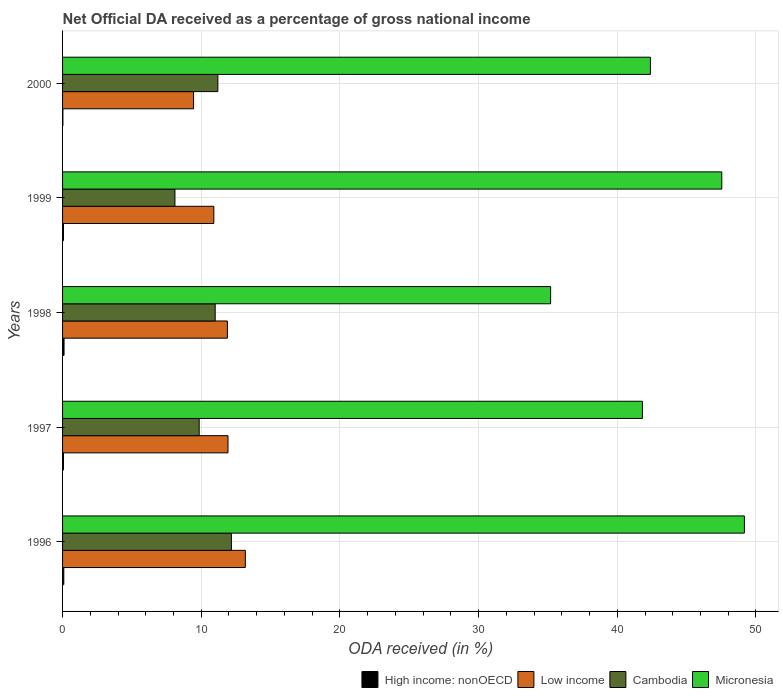How many different coloured bars are there?
Offer a terse response. 4. How many groups of bars are there?
Provide a succinct answer. 5. Are the number of bars per tick equal to the number of legend labels?
Make the answer very short. Yes. Are the number of bars on each tick of the Y-axis equal?
Provide a succinct answer. Yes. How many bars are there on the 4th tick from the bottom?
Offer a terse response. 4. What is the label of the 3rd group of bars from the top?
Your answer should be compact. 1998. In how many cases, is the number of bars for a given year not equal to the number of legend labels?
Keep it short and to the point. 0. What is the net official DA received in Cambodia in 1997?
Provide a succinct answer. 9.85. Across all years, what is the maximum net official DA received in Cambodia?
Offer a very short reply. 12.17. Across all years, what is the minimum net official DA received in Low income?
Your answer should be compact. 9.45. In which year was the net official DA received in Cambodia minimum?
Ensure brevity in your answer.  1999. What is the total net official DA received in High income: nonOECD in the graph?
Your response must be concise. 0.35. What is the difference between the net official DA received in Low income in 1999 and that in 2000?
Offer a terse response. 1.46. What is the difference between the net official DA received in Cambodia in 2000 and the net official DA received in Micronesia in 1998?
Provide a short and direct response. -24. What is the average net official DA received in Cambodia per year?
Your answer should be very brief. 10.47. In the year 1996, what is the difference between the net official DA received in Cambodia and net official DA received in Low income?
Your answer should be compact. -1.01. What is the ratio of the net official DA received in Micronesia in 1998 to that in 1999?
Ensure brevity in your answer.  0.74. Is the net official DA received in Micronesia in 1999 less than that in 2000?
Your answer should be very brief. No. Is the difference between the net official DA received in Cambodia in 1998 and 2000 greater than the difference between the net official DA received in Low income in 1998 and 2000?
Provide a succinct answer. No. What is the difference between the highest and the second highest net official DA received in High income: nonOECD?
Provide a short and direct response. 0.02. What is the difference between the highest and the lowest net official DA received in High income: nonOECD?
Ensure brevity in your answer.  0.08. In how many years, is the net official DA received in Cambodia greater than the average net official DA received in Cambodia taken over all years?
Make the answer very short. 3. Is the sum of the net official DA received in High income: nonOECD in 1996 and 1997 greater than the maximum net official DA received in Cambodia across all years?
Ensure brevity in your answer.  No. What does the 4th bar from the bottom in 1996 represents?
Provide a succinct answer. Micronesia. Is it the case that in every year, the sum of the net official DA received in High income: nonOECD and net official DA received in Cambodia is greater than the net official DA received in Low income?
Your answer should be very brief. No. How many bars are there?
Provide a short and direct response. 20. What is the difference between two consecutive major ticks on the X-axis?
Offer a very short reply. 10. Are the values on the major ticks of X-axis written in scientific E-notation?
Provide a short and direct response. No. Does the graph contain grids?
Offer a terse response. Yes. How are the legend labels stacked?
Provide a short and direct response. Horizontal. What is the title of the graph?
Offer a very short reply. Net Official DA received as a percentage of gross national income. What is the label or title of the X-axis?
Your answer should be very brief. ODA received (in %). What is the label or title of the Y-axis?
Offer a terse response. Years. What is the ODA received (in %) of High income: nonOECD in 1996?
Ensure brevity in your answer.  0.09. What is the ODA received (in %) in Low income in 1996?
Offer a very short reply. 13.18. What is the ODA received (in %) of Cambodia in 1996?
Provide a succinct answer. 12.17. What is the ODA received (in %) in Micronesia in 1996?
Your answer should be very brief. 49.17. What is the ODA received (in %) in High income: nonOECD in 1997?
Provide a succinct answer. 0.07. What is the ODA received (in %) in Low income in 1997?
Ensure brevity in your answer.  11.93. What is the ODA received (in %) of Cambodia in 1997?
Give a very brief answer. 9.85. What is the ODA received (in %) in Micronesia in 1997?
Provide a succinct answer. 41.81. What is the ODA received (in %) of High income: nonOECD in 1998?
Ensure brevity in your answer.  0.11. What is the ODA received (in %) of Low income in 1998?
Offer a very short reply. 11.89. What is the ODA received (in %) in Cambodia in 1998?
Offer a very short reply. 11.01. What is the ODA received (in %) in Micronesia in 1998?
Ensure brevity in your answer.  35.19. What is the ODA received (in %) of High income: nonOECD in 1999?
Provide a short and direct response. 0.07. What is the ODA received (in %) in Low income in 1999?
Your response must be concise. 10.91. What is the ODA received (in %) of Cambodia in 1999?
Provide a succinct answer. 8.1. What is the ODA received (in %) in Micronesia in 1999?
Provide a succinct answer. 47.54. What is the ODA received (in %) in High income: nonOECD in 2000?
Make the answer very short. 0.02. What is the ODA received (in %) in Low income in 2000?
Provide a short and direct response. 9.45. What is the ODA received (in %) in Cambodia in 2000?
Offer a very short reply. 11.2. What is the ODA received (in %) in Micronesia in 2000?
Provide a succinct answer. 42.39. Across all years, what is the maximum ODA received (in %) of High income: nonOECD?
Your answer should be very brief. 0.11. Across all years, what is the maximum ODA received (in %) in Low income?
Provide a succinct answer. 13.18. Across all years, what is the maximum ODA received (in %) in Cambodia?
Offer a very short reply. 12.17. Across all years, what is the maximum ODA received (in %) of Micronesia?
Your response must be concise. 49.17. Across all years, what is the minimum ODA received (in %) of High income: nonOECD?
Offer a very short reply. 0.02. Across all years, what is the minimum ODA received (in %) in Low income?
Provide a short and direct response. 9.45. Across all years, what is the minimum ODA received (in %) of Cambodia?
Give a very brief answer. 8.1. Across all years, what is the minimum ODA received (in %) in Micronesia?
Offer a terse response. 35.19. What is the total ODA received (in %) of High income: nonOECD in the graph?
Your answer should be compact. 0.35. What is the total ODA received (in %) in Low income in the graph?
Your response must be concise. 57.35. What is the total ODA received (in %) of Cambodia in the graph?
Make the answer very short. 52.33. What is the total ODA received (in %) of Micronesia in the graph?
Your answer should be very brief. 216.1. What is the difference between the ODA received (in %) of High income: nonOECD in 1996 and that in 1997?
Your response must be concise. 0.02. What is the difference between the ODA received (in %) in Low income in 1996 and that in 1997?
Make the answer very short. 1.25. What is the difference between the ODA received (in %) of Cambodia in 1996 and that in 1997?
Offer a very short reply. 2.32. What is the difference between the ODA received (in %) in Micronesia in 1996 and that in 1997?
Provide a short and direct response. 7.35. What is the difference between the ODA received (in %) of High income: nonOECD in 1996 and that in 1998?
Give a very brief answer. -0.02. What is the difference between the ODA received (in %) of Low income in 1996 and that in 1998?
Provide a short and direct response. 1.29. What is the difference between the ODA received (in %) in Cambodia in 1996 and that in 1998?
Make the answer very short. 1.17. What is the difference between the ODA received (in %) in Micronesia in 1996 and that in 1998?
Give a very brief answer. 13.97. What is the difference between the ODA received (in %) in High income: nonOECD in 1996 and that in 1999?
Your answer should be very brief. 0.02. What is the difference between the ODA received (in %) of Low income in 1996 and that in 1999?
Your response must be concise. 2.27. What is the difference between the ODA received (in %) of Cambodia in 1996 and that in 1999?
Provide a succinct answer. 4.07. What is the difference between the ODA received (in %) of Micronesia in 1996 and that in 1999?
Ensure brevity in your answer.  1.63. What is the difference between the ODA received (in %) in High income: nonOECD in 1996 and that in 2000?
Your answer should be very brief. 0.06. What is the difference between the ODA received (in %) of Low income in 1996 and that in 2000?
Provide a short and direct response. 3.73. What is the difference between the ODA received (in %) of Cambodia in 1996 and that in 2000?
Your answer should be very brief. 0.98. What is the difference between the ODA received (in %) in Micronesia in 1996 and that in 2000?
Your response must be concise. 6.78. What is the difference between the ODA received (in %) in High income: nonOECD in 1997 and that in 1998?
Give a very brief answer. -0.04. What is the difference between the ODA received (in %) in Low income in 1997 and that in 1998?
Give a very brief answer. 0.04. What is the difference between the ODA received (in %) of Cambodia in 1997 and that in 1998?
Offer a terse response. -1.15. What is the difference between the ODA received (in %) in Micronesia in 1997 and that in 1998?
Your answer should be compact. 6.62. What is the difference between the ODA received (in %) in High income: nonOECD in 1997 and that in 1999?
Make the answer very short. 0. What is the difference between the ODA received (in %) in Low income in 1997 and that in 1999?
Provide a succinct answer. 1.02. What is the difference between the ODA received (in %) of Cambodia in 1997 and that in 1999?
Ensure brevity in your answer.  1.75. What is the difference between the ODA received (in %) of Micronesia in 1997 and that in 1999?
Your answer should be very brief. -5.72. What is the difference between the ODA received (in %) in High income: nonOECD in 1997 and that in 2000?
Provide a short and direct response. 0.04. What is the difference between the ODA received (in %) of Low income in 1997 and that in 2000?
Give a very brief answer. 2.48. What is the difference between the ODA received (in %) of Cambodia in 1997 and that in 2000?
Provide a short and direct response. -1.35. What is the difference between the ODA received (in %) of Micronesia in 1997 and that in 2000?
Keep it short and to the point. -0.58. What is the difference between the ODA received (in %) of High income: nonOECD in 1998 and that in 1999?
Offer a very short reply. 0.04. What is the difference between the ODA received (in %) in Low income in 1998 and that in 1999?
Your answer should be compact. 0.98. What is the difference between the ODA received (in %) in Cambodia in 1998 and that in 1999?
Keep it short and to the point. 2.9. What is the difference between the ODA received (in %) in Micronesia in 1998 and that in 1999?
Provide a short and direct response. -12.34. What is the difference between the ODA received (in %) of High income: nonOECD in 1998 and that in 2000?
Your answer should be compact. 0.08. What is the difference between the ODA received (in %) in Low income in 1998 and that in 2000?
Make the answer very short. 2.44. What is the difference between the ODA received (in %) in Cambodia in 1998 and that in 2000?
Provide a short and direct response. -0.19. What is the difference between the ODA received (in %) of Micronesia in 1998 and that in 2000?
Provide a short and direct response. -7.2. What is the difference between the ODA received (in %) of High income: nonOECD in 1999 and that in 2000?
Make the answer very short. 0.04. What is the difference between the ODA received (in %) of Low income in 1999 and that in 2000?
Your answer should be very brief. 1.46. What is the difference between the ODA received (in %) of Cambodia in 1999 and that in 2000?
Offer a very short reply. -3.09. What is the difference between the ODA received (in %) in Micronesia in 1999 and that in 2000?
Keep it short and to the point. 5.15. What is the difference between the ODA received (in %) in High income: nonOECD in 1996 and the ODA received (in %) in Low income in 1997?
Provide a succinct answer. -11.84. What is the difference between the ODA received (in %) of High income: nonOECD in 1996 and the ODA received (in %) of Cambodia in 1997?
Keep it short and to the point. -9.76. What is the difference between the ODA received (in %) of High income: nonOECD in 1996 and the ODA received (in %) of Micronesia in 1997?
Your response must be concise. -41.72. What is the difference between the ODA received (in %) in Low income in 1996 and the ODA received (in %) in Cambodia in 1997?
Keep it short and to the point. 3.33. What is the difference between the ODA received (in %) of Low income in 1996 and the ODA received (in %) of Micronesia in 1997?
Keep it short and to the point. -28.63. What is the difference between the ODA received (in %) of Cambodia in 1996 and the ODA received (in %) of Micronesia in 1997?
Offer a terse response. -29.64. What is the difference between the ODA received (in %) of High income: nonOECD in 1996 and the ODA received (in %) of Low income in 1998?
Provide a short and direct response. -11.8. What is the difference between the ODA received (in %) in High income: nonOECD in 1996 and the ODA received (in %) in Cambodia in 1998?
Keep it short and to the point. -10.92. What is the difference between the ODA received (in %) of High income: nonOECD in 1996 and the ODA received (in %) of Micronesia in 1998?
Your answer should be very brief. -35.1. What is the difference between the ODA received (in %) of Low income in 1996 and the ODA received (in %) of Cambodia in 1998?
Ensure brevity in your answer.  2.17. What is the difference between the ODA received (in %) of Low income in 1996 and the ODA received (in %) of Micronesia in 1998?
Provide a succinct answer. -22.01. What is the difference between the ODA received (in %) of Cambodia in 1996 and the ODA received (in %) of Micronesia in 1998?
Offer a very short reply. -23.02. What is the difference between the ODA received (in %) in High income: nonOECD in 1996 and the ODA received (in %) in Low income in 1999?
Your response must be concise. -10.82. What is the difference between the ODA received (in %) in High income: nonOECD in 1996 and the ODA received (in %) in Cambodia in 1999?
Provide a short and direct response. -8.01. What is the difference between the ODA received (in %) in High income: nonOECD in 1996 and the ODA received (in %) in Micronesia in 1999?
Your answer should be very brief. -47.45. What is the difference between the ODA received (in %) in Low income in 1996 and the ODA received (in %) in Cambodia in 1999?
Ensure brevity in your answer.  5.08. What is the difference between the ODA received (in %) of Low income in 1996 and the ODA received (in %) of Micronesia in 1999?
Keep it short and to the point. -34.36. What is the difference between the ODA received (in %) in Cambodia in 1996 and the ODA received (in %) in Micronesia in 1999?
Make the answer very short. -35.36. What is the difference between the ODA received (in %) in High income: nonOECD in 1996 and the ODA received (in %) in Low income in 2000?
Provide a succinct answer. -9.36. What is the difference between the ODA received (in %) of High income: nonOECD in 1996 and the ODA received (in %) of Cambodia in 2000?
Offer a terse response. -11.11. What is the difference between the ODA received (in %) in High income: nonOECD in 1996 and the ODA received (in %) in Micronesia in 2000?
Your answer should be very brief. -42.3. What is the difference between the ODA received (in %) of Low income in 1996 and the ODA received (in %) of Cambodia in 2000?
Ensure brevity in your answer.  1.98. What is the difference between the ODA received (in %) in Low income in 1996 and the ODA received (in %) in Micronesia in 2000?
Offer a terse response. -29.21. What is the difference between the ODA received (in %) in Cambodia in 1996 and the ODA received (in %) in Micronesia in 2000?
Offer a very short reply. -30.22. What is the difference between the ODA received (in %) in High income: nonOECD in 1997 and the ODA received (in %) in Low income in 1998?
Give a very brief answer. -11.82. What is the difference between the ODA received (in %) in High income: nonOECD in 1997 and the ODA received (in %) in Cambodia in 1998?
Ensure brevity in your answer.  -10.94. What is the difference between the ODA received (in %) in High income: nonOECD in 1997 and the ODA received (in %) in Micronesia in 1998?
Make the answer very short. -35.13. What is the difference between the ODA received (in %) in Low income in 1997 and the ODA received (in %) in Cambodia in 1998?
Your response must be concise. 0.92. What is the difference between the ODA received (in %) of Low income in 1997 and the ODA received (in %) of Micronesia in 1998?
Give a very brief answer. -23.26. What is the difference between the ODA received (in %) in Cambodia in 1997 and the ODA received (in %) in Micronesia in 1998?
Make the answer very short. -25.34. What is the difference between the ODA received (in %) in High income: nonOECD in 1997 and the ODA received (in %) in Low income in 1999?
Offer a very short reply. -10.84. What is the difference between the ODA received (in %) of High income: nonOECD in 1997 and the ODA received (in %) of Cambodia in 1999?
Your response must be concise. -8.04. What is the difference between the ODA received (in %) of High income: nonOECD in 1997 and the ODA received (in %) of Micronesia in 1999?
Your answer should be very brief. -47.47. What is the difference between the ODA received (in %) in Low income in 1997 and the ODA received (in %) in Cambodia in 1999?
Provide a short and direct response. 3.83. What is the difference between the ODA received (in %) of Low income in 1997 and the ODA received (in %) of Micronesia in 1999?
Your response must be concise. -35.61. What is the difference between the ODA received (in %) of Cambodia in 1997 and the ODA received (in %) of Micronesia in 1999?
Keep it short and to the point. -37.68. What is the difference between the ODA received (in %) in High income: nonOECD in 1997 and the ODA received (in %) in Low income in 2000?
Your answer should be compact. -9.38. What is the difference between the ODA received (in %) in High income: nonOECD in 1997 and the ODA received (in %) in Cambodia in 2000?
Offer a terse response. -11.13. What is the difference between the ODA received (in %) in High income: nonOECD in 1997 and the ODA received (in %) in Micronesia in 2000?
Give a very brief answer. -42.32. What is the difference between the ODA received (in %) in Low income in 1997 and the ODA received (in %) in Cambodia in 2000?
Ensure brevity in your answer.  0.73. What is the difference between the ODA received (in %) in Low income in 1997 and the ODA received (in %) in Micronesia in 2000?
Keep it short and to the point. -30.46. What is the difference between the ODA received (in %) in Cambodia in 1997 and the ODA received (in %) in Micronesia in 2000?
Your answer should be very brief. -32.54. What is the difference between the ODA received (in %) of High income: nonOECD in 1998 and the ODA received (in %) of Low income in 1999?
Provide a short and direct response. -10.8. What is the difference between the ODA received (in %) in High income: nonOECD in 1998 and the ODA received (in %) in Cambodia in 1999?
Offer a very short reply. -8. What is the difference between the ODA received (in %) of High income: nonOECD in 1998 and the ODA received (in %) of Micronesia in 1999?
Offer a very short reply. -47.43. What is the difference between the ODA received (in %) in Low income in 1998 and the ODA received (in %) in Cambodia in 1999?
Your response must be concise. 3.78. What is the difference between the ODA received (in %) in Low income in 1998 and the ODA received (in %) in Micronesia in 1999?
Offer a very short reply. -35.65. What is the difference between the ODA received (in %) of Cambodia in 1998 and the ODA received (in %) of Micronesia in 1999?
Your response must be concise. -36.53. What is the difference between the ODA received (in %) in High income: nonOECD in 1998 and the ODA received (in %) in Low income in 2000?
Ensure brevity in your answer.  -9.34. What is the difference between the ODA received (in %) in High income: nonOECD in 1998 and the ODA received (in %) in Cambodia in 2000?
Your response must be concise. -11.09. What is the difference between the ODA received (in %) in High income: nonOECD in 1998 and the ODA received (in %) in Micronesia in 2000?
Keep it short and to the point. -42.28. What is the difference between the ODA received (in %) of Low income in 1998 and the ODA received (in %) of Cambodia in 2000?
Offer a terse response. 0.69. What is the difference between the ODA received (in %) in Low income in 1998 and the ODA received (in %) in Micronesia in 2000?
Offer a terse response. -30.5. What is the difference between the ODA received (in %) in Cambodia in 1998 and the ODA received (in %) in Micronesia in 2000?
Keep it short and to the point. -31.38. What is the difference between the ODA received (in %) of High income: nonOECD in 1999 and the ODA received (in %) of Low income in 2000?
Your response must be concise. -9.38. What is the difference between the ODA received (in %) of High income: nonOECD in 1999 and the ODA received (in %) of Cambodia in 2000?
Offer a terse response. -11.13. What is the difference between the ODA received (in %) in High income: nonOECD in 1999 and the ODA received (in %) in Micronesia in 2000?
Your response must be concise. -42.32. What is the difference between the ODA received (in %) of Low income in 1999 and the ODA received (in %) of Cambodia in 2000?
Offer a terse response. -0.29. What is the difference between the ODA received (in %) in Low income in 1999 and the ODA received (in %) in Micronesia in 2000?
Provide a succinct answer. -31.48. What is the difference between the ODA received (in %) of Cambodia in 1999 and the ODA received (in %) of Micronesia in 2000?
Provide a succinct answer. -34.29. What is the average ODA received (in %) of High income: nonOECD per year?
Give a very brief answer. 0.07. What is the average ODA received (in %) of Low income per year?
Provide a short and direct response. 11.47. What is the average ODA received (in %) in Cambodia per year?
Offer a terse response. 10.47. What is the average ODA received (in %) in Micronesia per year?
Provide a succinct answer. 43.22. In the year 1996, what is the difference between the ODA received (in %) of High income: nonOECD and ODA received (in %) of Low income?
Keep it short and to the point. -13.09. In the year 1996, what is the difference between the ODA received (in %) of High income: nonOECD and ODA received (in %) of Cambodia?
Offer a very short reply. -12.09. In the year 1996, what is the difference between the ODA received (in %) of High income: nonOECD and ODA received (in %) of Micronesia?
Ensure brevity in your answer.  -49.08. In the year 1996, what is the difference between the ODA received (in %) of Low income and ODA received (in %) of Cambodia?
Offer a very short reply. 1.01. In the year 1996, what is the difference between the ODA received (in %) of Low income and ODA received (in %) of Micronesia?
Give a very brief answer. -35.99. In the year 1996, what is the difference between the ODA received (in %) of Cambodia and ODA received (in %) of Micronesia?
Your answer should be compact. -36.99. In the year 1997, what is the difference between the ODA received (in %) of High income: nonOECD and ODA received (in %) of Low income?
Keep it short and to the point. -11.86. In the year 1997, what is the difference between the ODA received (in %) in High income: nonOECD and ODA received (in %) in Cambodia?
Your answer should be very brief. -9.78. In the year 1997, what is the difference between the ODA received (in %) of High income: nonOECD and ODA received (in %) of Micronesia?
Provide a short and direct response. -41.74. In the year 1997, what is the difference between the ODA received (in %) of Low income and ODA received (in %) of Cambodia?
Offer a terse response. 2.08. In the year 1997, what is the difference between the ODA received (in %) in Low income and ODA received (in %) in Micronesia?
Your answer should be very brief. -29.88. In the year 1997, what is the difference between the ODA received (in %) in Cambodia and ODA received (in %) in Micronesia?
Your answer should be compact. -31.96. In the year 1998, what is the difference between the ODA received (in %) of High income: nonOECD and ODA received (in %) of Low income?
Provide a short and direct response. -11.78. In the year 1998, what is the difference between the ODA received (in %) in High income: nonOECD and ODA received (in %) in Cambodia?
Ensure brevity in your answer.  -10.9. In the year 1998, what is the difference between the ODA received (in %) in High income: nonOECD and ODA received (in %) in Micronesia?
Give a very brief answer. -35.09. In the year 1998, what is the difference between the ODA received (in %) of Low income and ODA received (in %) of Cambodia?
Provide a short and direct response. 0.88. In the year 1998, what is the difference between the ODA received (in %) in Low income and ODA received (in %) in Micronesia?
Give a very brief answer. -23.31. In the year 1998, what is the difference between the ODA received (in %) of Cambodia and ODA received (in %) of Micronesia?
Your answer should be very brief. -24.19. In the year 1999, what is the difference between the ODA received (in %) in High income: nonOECD and ODA received (in %) in Low income?
Keep it short and to the point. -10.84. In the year 1999, what is the difference between the ODA received (in %) of High income: nonOECD and ODA received (in %) of Cambodia?
Keep it short and to the point. -8.04. In the year 1999, what is the difference between the ODA received (in %) in High income: nonOECD and ODA received (in %) in Micronesia?
Ensure brevity in your answer.  -47.47. In the year 1999, what is the difference between the ODA received (in %) in Low income and ODA received (in %) in Cambodia?
Your answer should be very brief. 2.8. In the year 1999, what is the difference between the ODA received (in %) in Low income and ODA received (in %) in Micronesia?
Make the answer very short. -36.63. In the year 1999, what is the difference between the ODA received (in %) of Cambodia and ODA received (in %) of Micronesia?
Make the answer very short. -39.43. In the year 2000, what is the difference between the ODA received (in %) of High income: nonOECD and ODA received (in %) of Low income?
Your answer should be compact. -9.42. In the year 2000, what is the difference between the ODA received (in %) in High income: nonOECD and ODA received (in %) in Cambodia?
Provide a succinct answer. -11.17. In the year 2000, what is the difference between the ODA received (in %) in High income: nonOECD and ODA received (in %) in Micronesia?
Provide a succinct answer. -42.37. In the year 2000, what is the difference between the ODA received (in %) of Low income and ODA received (in %) of Cambodia?
Ensure brevity in your answer.  -1.75. In the year 2000, what is the difference between the ODA received (in %) in Low income and ODA received (in %) in Micronesia?
Provide a succinct answer. -32.94. In the year 2000, what is the difference between the ODA received (in %) of Cambodia and ODA received (in %) of Micronesia?
Provide a short and direct response. -31.19. What is the ratio of the ODA received (in %) of High income: nonOECD in 1996 to that in 1997?
Offer a terse response. 1.31. What is the ratio of the ODA received (in %) in Low income in 1996 to that in 1997?
Make the answer very short. 1.1. What is the ratio of the ODA received (in %) of Cambodia in 1996 to that in 1997?
Give a very brief answer. 1.24. What is the ratio of the ODA received (in %) in Micronesia in 1996 to that in 1997?
Make the answer very short. 1.18. What is the ratio of the ODA received (in %) in High income: nonOECD in 1996 to that in 1998?
Make the answer very short. 0.83. What is the ratio of the ODA received (in %) of Low income in 1996 to that in 1998?
Provide a succinct answer. 1.11. What is the ratio of the ODA received (in %) of Cambodia in 1996 to that in 1998?
Make the answer very short. 1.11. What is the ratio of the ODA received (in %) in Micronesia in 1996 to that in 1998?
Make the answer very short. 1.4. What is the ratio of the ODA received (in %) in High income: nonOECD in 1996 to that in 1999?
Keep it short and to the point. 1.34. What is the ratio of the ODA received (in %) of Low income in 1996 to that in 1999?
Keep it short and to the point. 1.21. What is the ratio of the ODA received (in %) of Cambodia in 1996 to that in 1999?
Keep it short and to the point. 1.5. What is the ratio of the ODA received (in %) of Micronesia in 1996 to that in 1999?
Give a very brief answer. 1.03. What is the ratio of the ODA received (in %) in High income: nonOECD in 1996 to that in 2000?
Your answer should be compact. 3.55. What is the ratio of the ODA received (in %) of Low income in 1996 to that in 2000?
Ensure brevity in your answer.  1.4. What is the ratio of the ODA received (in %) of Cambodia in 1996 to that in 2000?
Your response must be concise. 1.09. What is the ratio of the ODA received (in %) in Micronesia in 1996 to that in 2000?
Provide a short and direct response. 1.16. What is the ratio of the ODA received (in %) in High income: nonOECD in 1997 to that in 1998?
Your answer should be compact. 0.64. What is the ratio of the ODA received (in %) in Low income in 1997 to that in 1998?
Your response must be concise. 1. What is the ratio of the ODA received (in %) of Cambodia in 1997 to that in 1998?
Make the answer very short. 0.9. What is the ratio of the ODA received (in %) in Micronesia in 1997 to that in 1998?
Offer a terse response. 1.19. What is the ratio of the ODA received (in %) of High income: nonOECD in 1997 to that in 1999?
Your response must be concise. 1.03. What is the ratio of the ODA received (in %) in Low income in 1997 to that in 1999?
Offer a very short reply. 1.09. What is the ratio of the ODA received (in %) in Cambodia in 1997 to that in 1999?
Make the answer very short. 1.22. What is the ratio of the ODA received (in %) of Micronesia in 1997 to that in 1999?
Your answer should be compact. 0.88. What is the ratio of the ODA received (in %) of High income: nonOECD in 1997 to that in 2000?
Your response must be concise. 2.72. What is the ratio of the ODA received (in %) in Low income in 1997 to that in 2000?
Ensure brevity in your answer.  1.26. What is the ratio of the ODA received (in %) of Cambodia in 1997 to that in 2000?
Keep it short and to the point. 0.88. What is the ratio of the ODA received (in %) of Micronesia in 1997 to that in 2000?
Make the answer very short. 0.99. What is the ratio of the ODA received (in %) in High income: nonOECD in 1998 to that in 1999?
Your answer should be compact. 1.61. What is the ratio of the ODA received (in %) of Low income in 1998 to that in 1999?
Your response must be concise. 1.09. What is the ratio of the ODA received (in %) in Cambodia in 1998 to that in 1999?
Your response must be concise. 1.36. What is the ratio of the ODA received (in %) of Micronesia in 1998 to that in 1999?
Your answer should be compact. 0.74. What is the ratio of the ODA received (in %) of High income: nonOECD in 1998 to that in 2000?
Make the answer very short. 4.27. What is the ratio of the ODA received (in %) of Low income in 1998 to that in 2000?
Offer a very short reply. 1.26. What is the ratio of the ODA received (in %) in Cambodia in 1998 to that in 2000?
Offer a very short reply. 0.98. What is the ratio of the ODA received (in %) of Micronesia in 1998 to that in 2000?
Make the answer very short. 0.83. What is the ratio of the ODA received (in %) in High income: nonOECD in 1999 to that in 2000?
Keep it short and to the point. 2.65. What is the ratio of the ODA received (in %) in Low income in 1999 to that in 2000?
Your response must be concise. 1.15. What is the ratio of the ODA received (in %) of Cambodia in 1999 to that in 2000?
Provide a short and direct response. 0.72. What is the ratio of the ODA received (in %) of Micronesia in 1999 to that in 2000?
Your response must be concise. 1.12. What is the difference between the highest and the second highest ODA received (in %) of High income: nonOECD?
Offer a very short reply. 0.02. What is the difference between the highest and the second highest ODA received (in %) of Low income?
Make the answer very short. 1.25. What is the difference between the highest and the second highest ODA received (in %) of Cambodia?
Provide a succinct answer. 0.98. What is the difference between the highest and the second highest ODA received (in %) of Micronesia?
Provide a short and direct response. 1.63. What is the difference between the highest and the lowest ODA received (in %) of High income: nonOECD?
Your answer should be compact. 0.08. What is the difference between the highest and the lowest ODA received (in %) in Low income?
Your answer should be very brief. 3.73. What is the difference between the highest and the lowest ODA received (in %) of Cambodia?
Provide a succinct answer. 4.07. What is the difference between the highest and the lowest ODA received (in %) of Micronesia?
Keep it short and to the point. 13.97. 